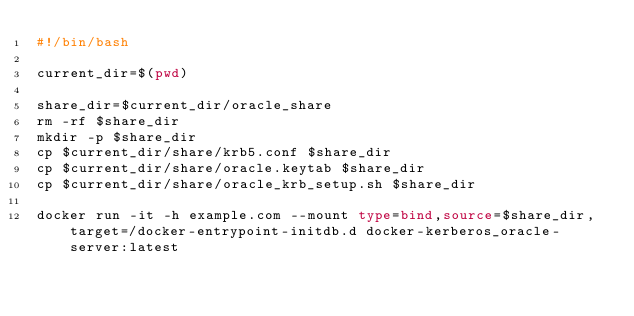Convert code to text. <code><loc_0><loc_0><loc_500><loc_500><_Bash_>#!/bin/bash

current_dir=$(pwd)

share_dir=$current_dir/oracle_share
rm -rf $share_dir
mkdir -p $share_dir
cp $current_dir/share/krb5.conf $share_dir
cp $current_dir/share/oracle.keytab $share_dir
cp $current_dir/share/oracle_krb_setup.sh $share_dir

docker run -it -h example.com --mount type=bind,source=$share_dir,target=/docker-entrypoint-initdb.d docker-kerberos_oracle-server:latest
</code> 